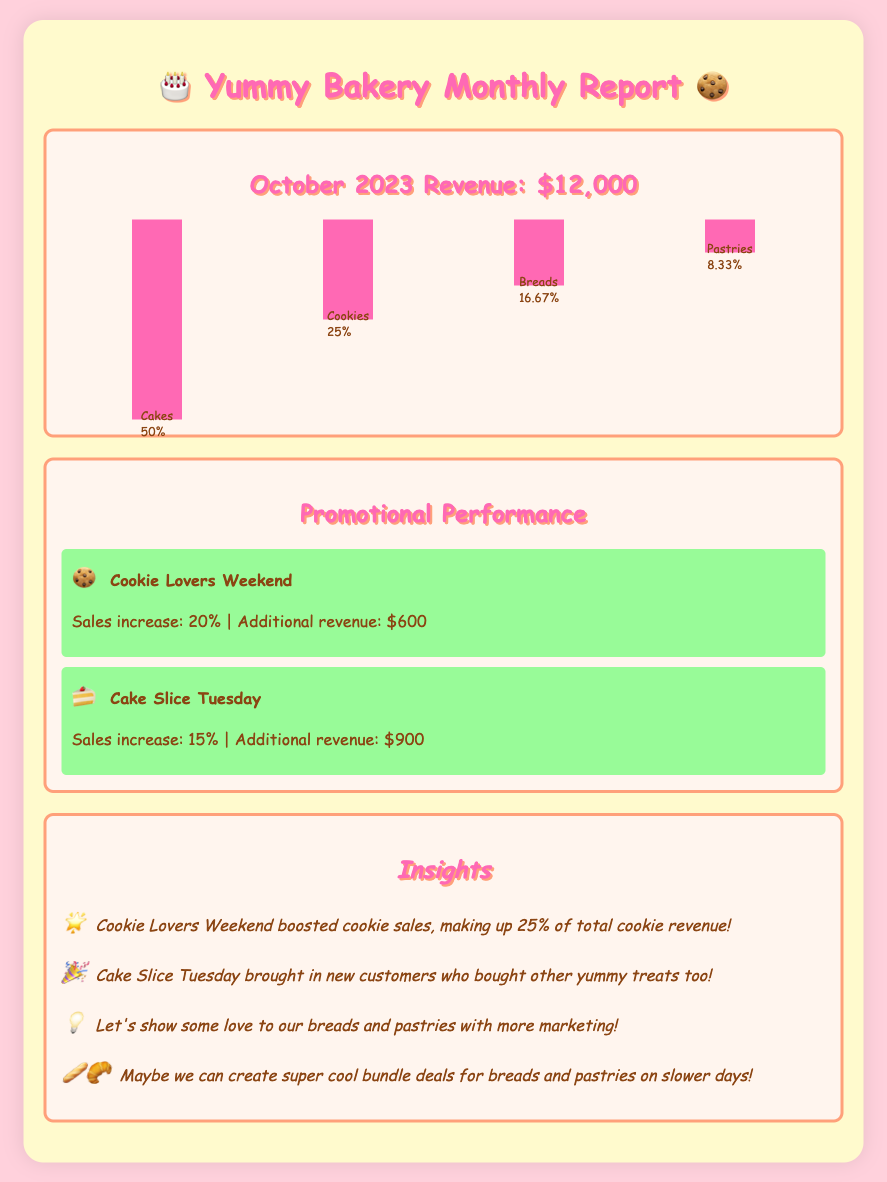What is the total revenue for October 2023? The total revenue for the month is stated in the document as October 2023 Revenue: $12,000.
Answer: $12,000 What percentage of total sales came from cakes? The document shows that cakes contributed 50% to the total sales according to the sales breakdown.
Answer: 50% How much additional revenue did the Cake Slice Tuesday promotion generate? The additional revenue generated from Cake Slice Tuesday is mentioned in the promotion section as $900.
Answer: $900 What was the sales increase from the Cookie Lovers Weekend promotion? The sales increase from the Cookie Lovers Weekend is specified as 20% in the promotional performance insights.
Answer: 20% What category does the lowest sales percentage belong to? The lowest sales percentage, as indicated in the sales breakdown, is attributed to pastries, which is 8.33%.
Answer: Pastries Which promotional event generated a 15% sales increase? The document states that the Cake Slice Tuesday event resulted in a 15% sales increase.
Answer: Cake Slice Tuesday How much revenue did cookies contribute in total? Cookies contributed 25% to the overall revenue according to the sales breakdown. Assuming the total revenue is $12,000, this can be calculated as $12,000 * 0.25 = $3,000.
Answer: $3,000 What is suggested to boost sales for breads and pastries? The insights suggest showing more love to breads and pastries with additional marketing strategies.
Answer: More marketing What can be created for slower sales days according to the insights? The insights recommend creating super cool bundle deals for breads and pastries on slower days to drive sales.
Answer: Bundle deals 